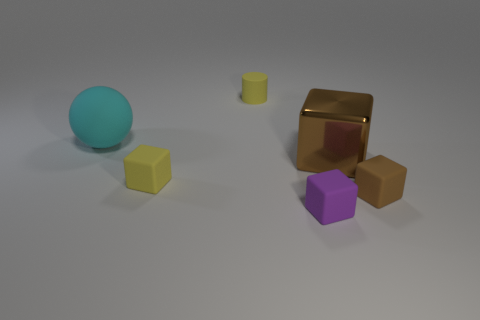Subtract all green balls. Subtract all brown cubes. How many balls are left? 1 Add 2 small red matte cylinders. How many objects exist? 8 Subtract all cylinders. How many objects are left? 5 Add 2 large cubes. How many large cubes exist? 3 Subtract 1 cyan spheres. How many objects are left? 5 Subtract all cyan metallic cylinders. Subtract all small matte blocks. How many objects are left? 3 Add 2 tiny yellow objects. How many tiny yellow objects are left? 4 